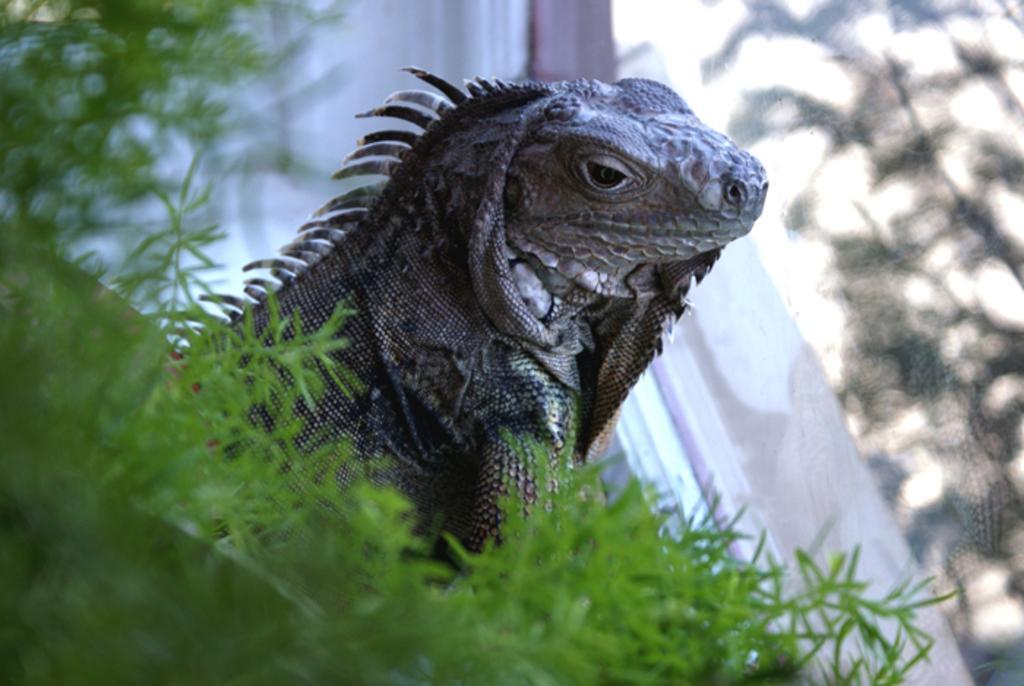Can you describe this image briefly? In the foreground of this image, there is a plant. Behind it, there is a garden lizard. On the right, it seems like a glass in the background. 